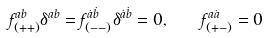Convert formula to latex. <formula><loc_0><loc_0><loc_500><loc_500>f ^ { a b } _ { ( + + ) } \delta ^ { a b } = f ^ { \dot { a } \dot { b } } _ { ( - - ) } \delta ^ { \dot { a } \dot { b } } = 0 , \quad f ^ { a \dot { a } } _ { ( + - ) } = 0</formula> 